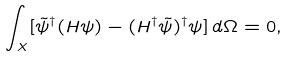<formula> <loc_0><loc_0><loc_500><loc_500>\int _ { X } [ { \tilde { \psi } } ^ { \dag } ( H \psi ) - ( H ^ { \dag } \tilde { \psi } ) ^ { \dag } \psi ] \, d \Omega = 0 ,</formula> 